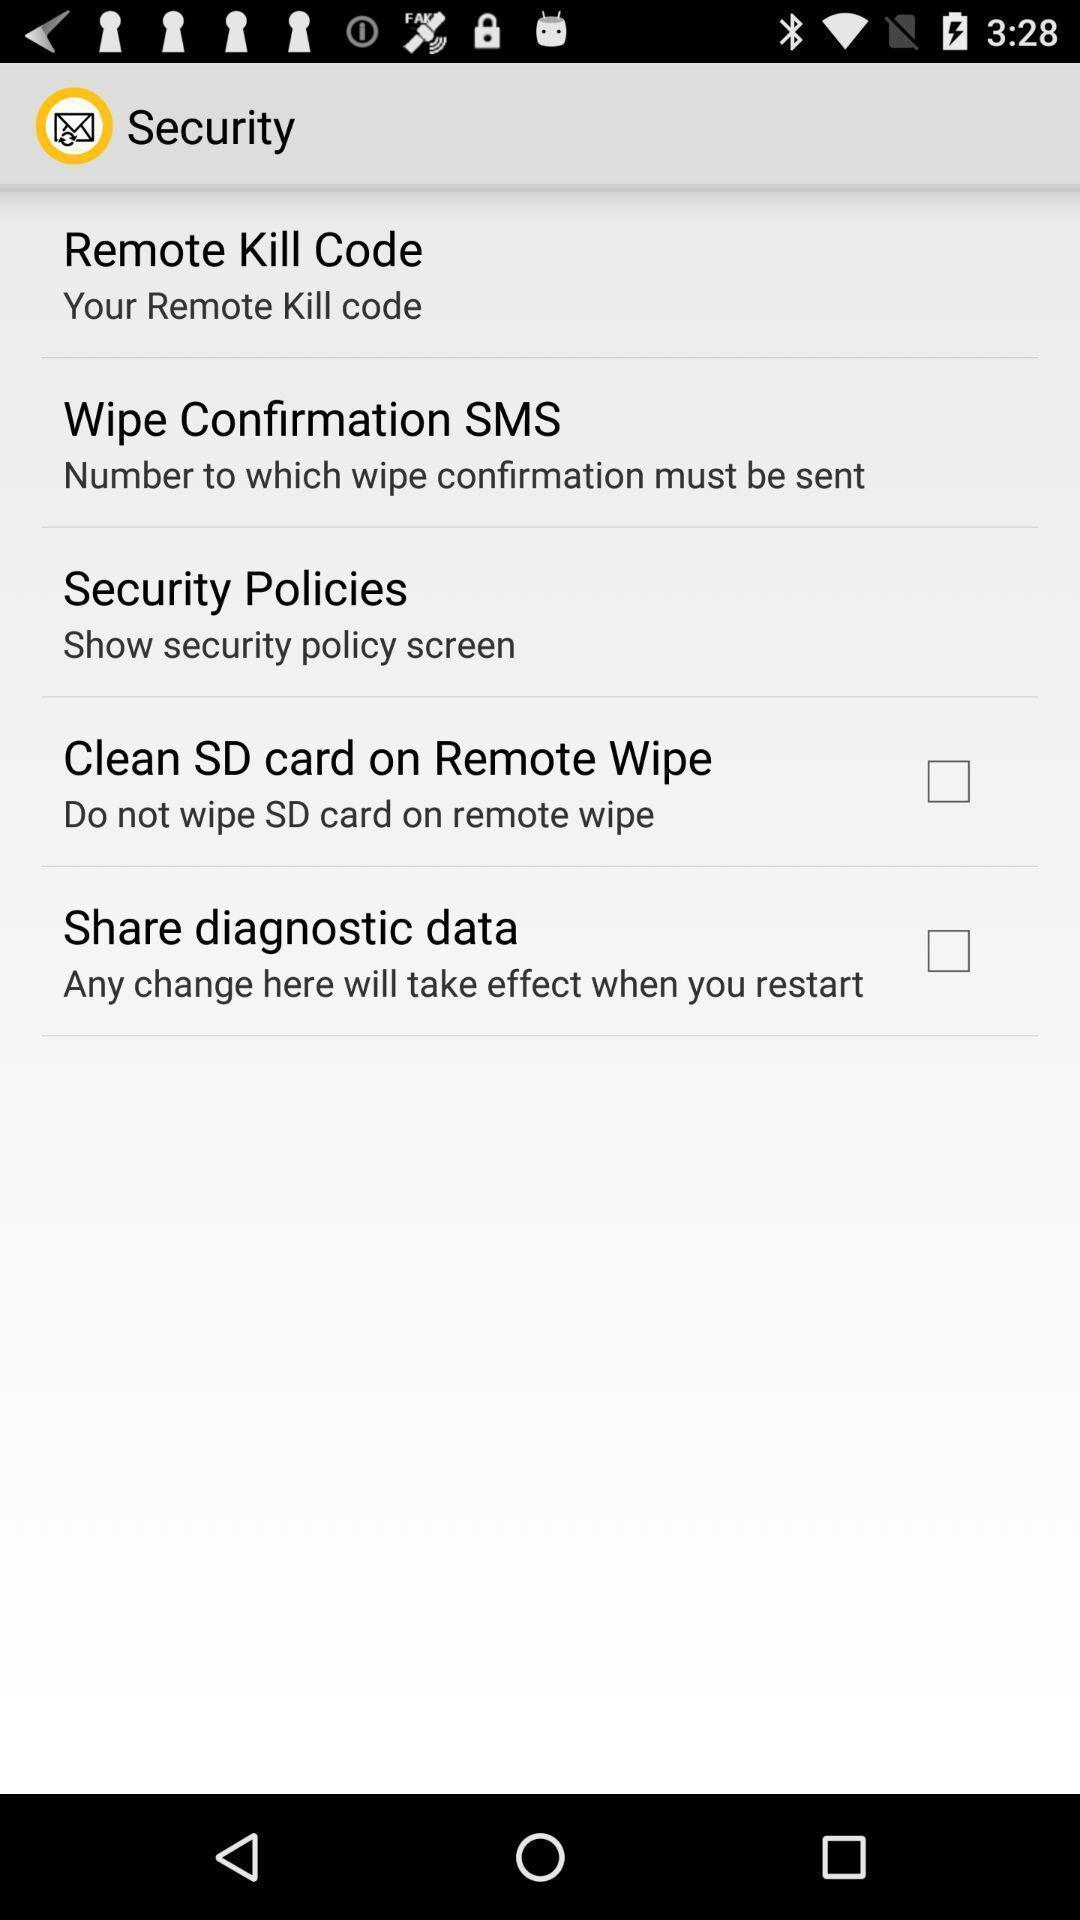Summarize the information in this screenshot. Security page displayed. 